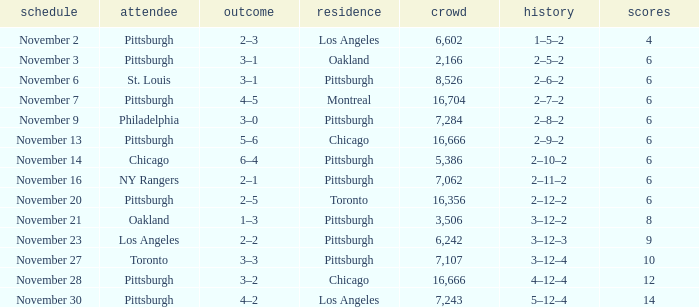What is the sum of the points of the game with philadelphia as the visitor and an attendance greater than 7,284? None. 